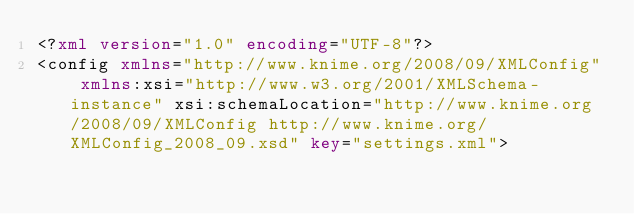<code> <loc_0><loc_0><loc_500><loc_500><_XML_><?xml version="1.0" encoding="UTF-8"?>
<config xmlns="http://www.knime.org/2008/09/XMLConfig" xmlns:xsi="http://www.w3.org/2001/XMLSchema-instance" xsi:schemaLocation="http://www.knime.org/2008/09/XMLConfig http://www.knime.org/XMLConfig_2008_09.xsd" key="settings.xml"></code> 